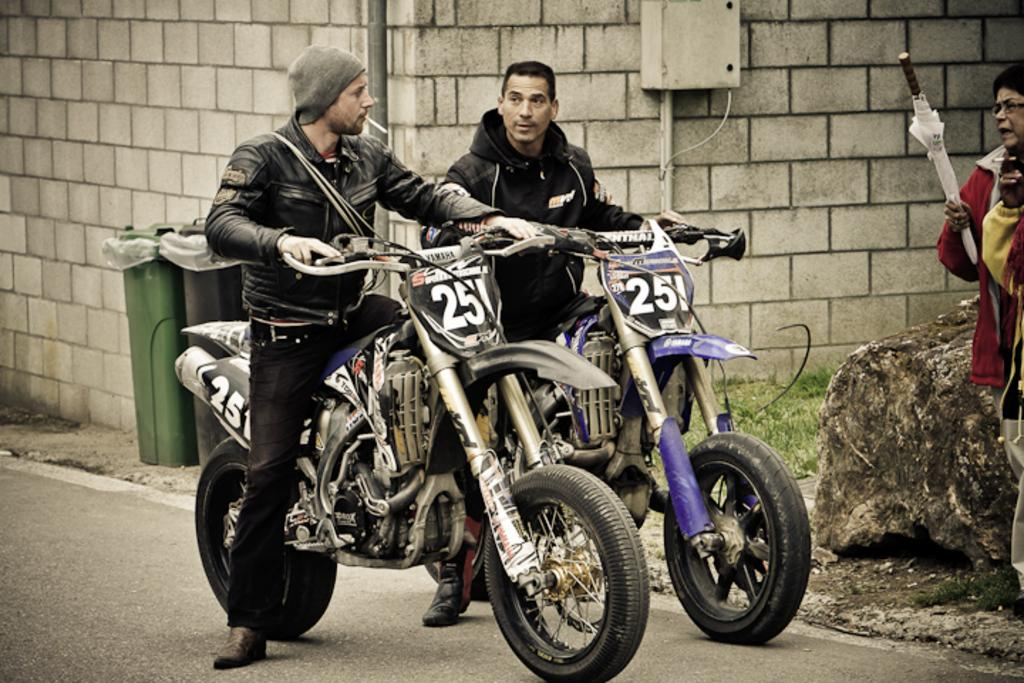How many people are in the image? There are three people in the image. What are the people doing in the image? The people are standing. What are two of the people holding in the image? Two of the people are holding a handle. What can be seen in the background of the image? There is a wall and a dustbin visible in the background of the image. How many mice can be seen running across the bridge in the image? There are no mice or bridges present in the image. What type of recess is visible in the image? There is no recess visible in the image. 